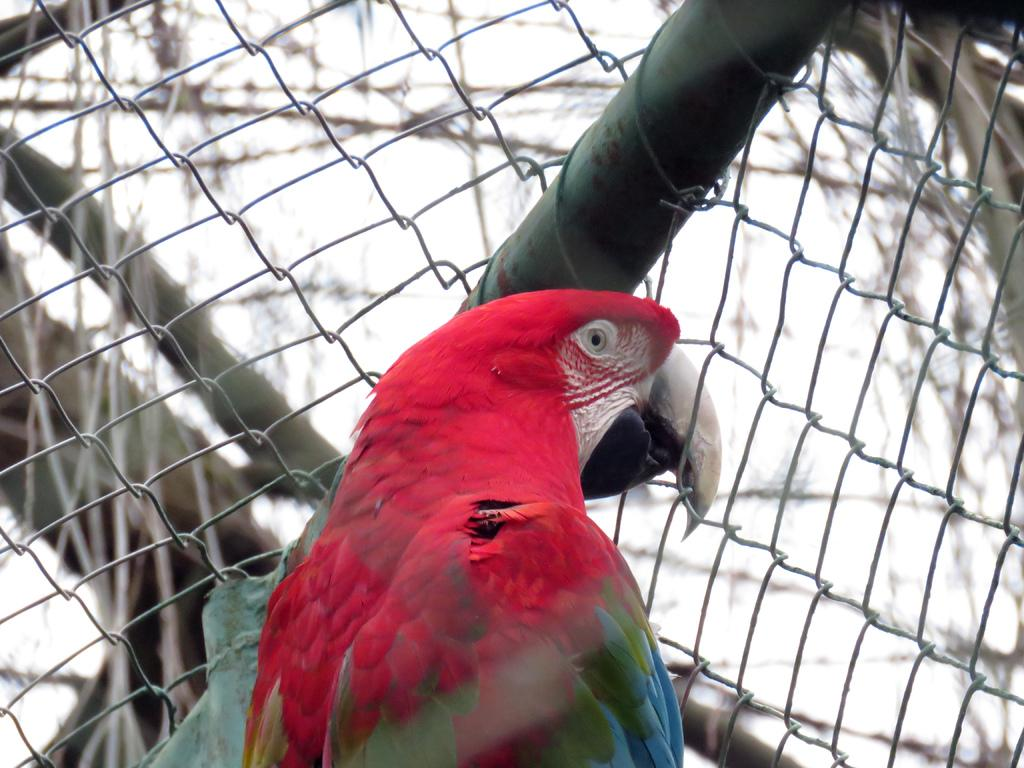What type of animal is present in the image? There is a bird in the image. Can you describe the appearance of the bird? The bird is colorful. Where is the bird located in relation to other objects in the image? The bird is in front of a railing. What is the color of the background in the image? The background in the image is white. Is the bird in the image a fictional character from a popular children's story? There is no indication in the image that the bird is a fictional character from a popular children's story. 